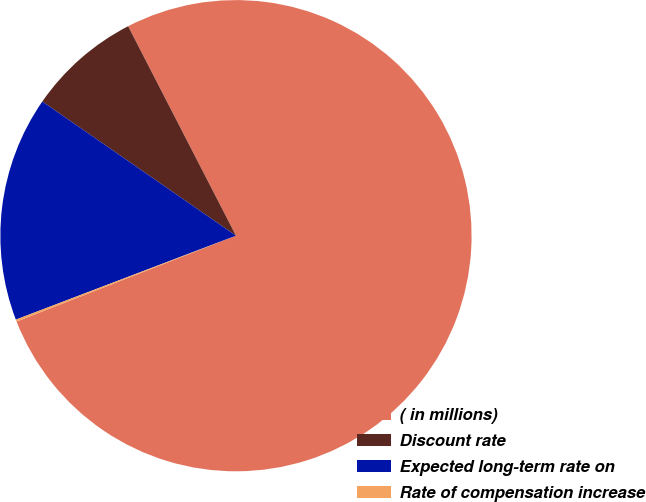Convert chart. <chart><loc_0><loc_0><loc_500><loc_500><pie_chart><fcel>( in millions)<fcel>Discount rate<fcel>Expected long-term rate on<fcel>Rate of compensation increase<nl><fcel>76.63%<fcel>7.79%<fcel>15.44%<fcel>0.14%<nl></chart> 